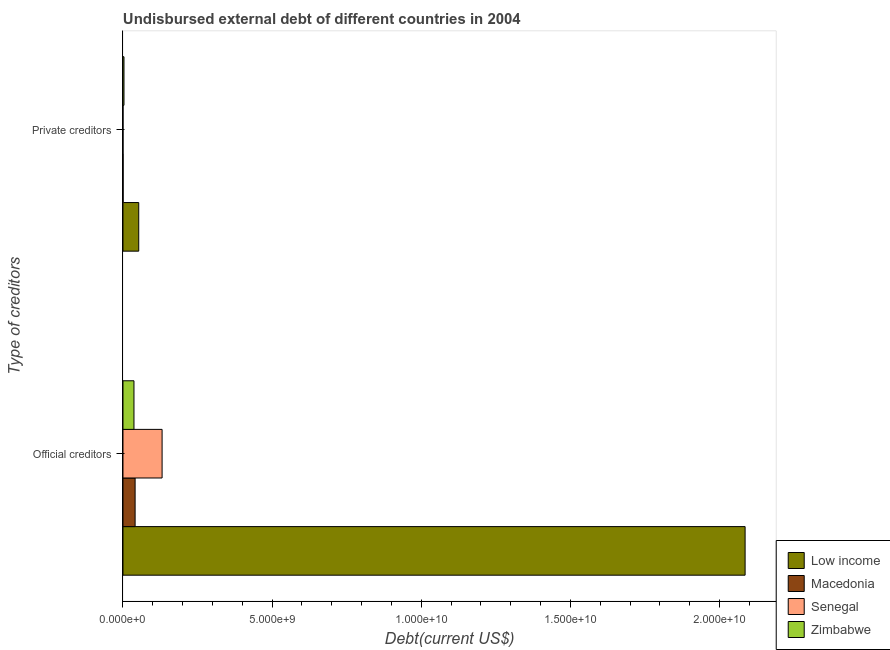How many different coloured bars are there?
Keep it short and to the point. 4. Are the number of bars per tick equal to the number of legend labels?
Your response must be concise. Yes. Are the number of bars on each tick of the Y-axis equal?
Your response must be concise. Yes. How many bars are there on the 2nd tick from the top?
Make the answer very short. 4. What is the label of the 2nd group of bars from the top?
Offer a very short reply. Official creditors. What is the undisbursed external debt of private creditors in Low income?
Provide a succinct answer. 5.28e+08. Across all countries, what is the maximum undisbursed external debt of private creditors?
Offer a very short reply. 5.28e+08. Across all countries, what is the minimum undisbursed external debt of private creditors?
Your response must be concise. 1.41e+05. In which country was the undisbursed external debt of private creditors maximum?
Offer a very short reply. Low income. In which country was the undisbursed external debt of private creditors minimum?
Offer a very short reply. Senegal. What is the total undisbursed external debt of private creditors in the graph?
Provide a short and direct response. 5.66e+08. What is the difference between the undisbursed external debt of official creditors in Low income and that in Senegal?
Provide a succinct answer. 1.95e+1. What is the difference between the undisbursed external debt of official creditors in Senegal and the undisbursed external debt of private creditors in Macedonia?
Your response must be concise. 1.31e+09. What is the average undisbursed external debt of official creditors per country?
Offer a very short reply. 5.74e+09. What is the difference between the undisbursed external debt of private creditors and undisbursed external debt of official creditors in Senegal?
Your answer should be compact. -1.31e+09. What is the ratio of the undisbursed external debt of private creditors in Macedonia to that in Low income?
Offer a very short reply. 0.01. Is the undisbursed external debt of official creditors in Low income less than that in Senegal?
Your answer should be very brief. No. In how many countries, is the undisbursed external debt of official creditors greater than the average undisbursed external debt of official creditors taken over all countries?
Give a very brief answer. 1. What does the 4th bar from the top in Official creditors represents?
Ensure brevity in your answer.  Low income. What does the 4th bar from the bottom in Private creditors represents?
Offer a very short reply. Zimbabwe. Are all the bars in the graph horizontal?
Make the answer very short. Yes. Does the graph contain any zero values?
Provide a succinct answer. No. Does the graph contain grids?
Make the answer very short. No. How many legend labels are there?
Your answer should be compact. 4. What is the title of the graph?
Make the answer very short. Undisbursed external debt of different countries in 2004. What is the label or title of the X-axis?
Your answer should be compact. Debt(current US$). What is the label or title of the Y-axis?
Offer a terse response. Type of creditors. What is the Debt(current US$) in Low income in Official creditors?
Ensure brevity in your answer.  2.09e+1. What is the Debt(current US$) of Macedonia in Official creditors?
Give a very brief answer. 4.07e+08. What is the Debt(current US$) of Senegal in Official creditors?
Keep it short and to the point. 1.31e+09. What is the Debt(current US$) of Zimbabwe in Official creditors?
Give a very brief answer. 3.68e+08. What is the Debt(current US$) in Low income in Private creditors?
Offer a very short reply. 5.28e+08. What is the Debt(current US$) in Macedonia in Private creditors?
Make the answer very short. 4.01e+06. What is the Debt(current US$) of Senegal in Private creditors?
Provide a succinct answer. 1.41e+05. What is the Debt(current US$) in Zimbabwe in Private creditors?
Offer a very short reply. 3.38e+07. Across all Type of creditors, what is the maximum Debt(current US$) of Low income?
Your response must be concise. 2.09e+1. Across all Type of creditors, what is the maximum Debt(current US$) of Macedonia?
Ensure brevity in your answer.  4.07e+08. Across all Type of creditors, what is the maximum Debt(current US$) of Senegal?
Offer a very short reply. 1.31e+09. Across all Type of creditors, what is the maximum Debt(current US$) of Zimbabwe?
Give a very brief answer. 3.68e+08. Across all Type of creditors, what is the minimum Debt(current US$) in Low income?
Offer a terse response. 5.28e+08. Across all Type of creditors, what is the minimum Debt(current US$) in Macedonia?
Provide a short and direct response. 4.01e+06. Across all Type of creditors, what is the minimum Debt(current US$) in Senegal?
Your response must be concise. 1.41e+05. Across all Type of creditors, what is the minimum Debt(current US$) of Zimbabwe?
Your response must be concise. 3.38e+07. What is the total Debt(current US$) in Low income in the graph?
Your answer should be very brief. 2.14e+1. What is the total Debt(current US$) in Macedonia in the graph?
Give a very brief answer. 4.11e+08. What is the total Debt(current US$) of Senegal in the graph?
Your answer should be very brief. 1.31e+09. What is the total Debt(current US$) in Zimbabwe in the graph?
Provide a short and direct response. 4.02e+08. What is the difference between the Debt(current US$) in Low income in Official creditors and that in Private creditors?
Provide a short and direct response. 2.03e+1. What is the difference between the Debt(current US$) in Macedonia in Official creditors and that in Private creditors?
Your response must be concise. 4.03e+08. What is the difference between the Debt(current US$) of Senegal in Official creditors and that in Private creditors?
Your response must be concise. 1.31e+09. What is the difference between the Debt(current US$) in Zimbabwe in Official creditors and that in Private creditors?
Provide a short and direct response. 3.35e+08. What is the difference between the Debt(current US$) of Low income in Official creditors and the Debt(current US$) of Macedonia in Private creditors?
Your answer should be compact. 2.09e+1. What is the difference between the Debt(current US$) of Low income in Official creditors and the Debt(current US$) of Senegal in Private creditors?
Give a very brief answer. 2.09e+1. What is the difference between the Debt(current US$) of Low income in Official creditors and the Debt(current US$) of Zimbabwe in Private creditors?
Your answer should be very brief. 2.08e+1. What is the difference between the Debt(current US$) in Macedonia in Official creditors and the Debt(current US$) in Senegal in Private creditors?
Give a very brief answer. 4.07e+08. What is the difference between the Debt(current US$) of Macedonia in Official creditors and the Debt(current US$) of Zimbabwe in Private creditors?
Give a very brief answer. 3.73e+08. What is the difference between the Debt(current US$) in Senegal in Official creditors and the Debt(current US$) in Zimbabwe in Private creditors?
Give a very brief answer. 1.28e+09. What is the average Debt(current US$) in Low income per Type of creditors?
Your response must be concise. 1.07e+1. What is the average Debt(current US$) of Macedonia per Type of creditors?
Give a very brief answer. 2.05e+08. What is the average Debt(current US$) of Senegal per Type of creditors?
Your response must be concise. 6.56e+08. What is the average Debt(current US$) in Zimbabwe per Type of creditors?
Your response must be concise. 2.01e+08. What is the difference between the Debt(current US$) in Low income and Debt(current US$) in Macedonia in Official creditors?
Keep it short and to the point. 2.04e+1. What is the difference between the Debt(current US$) of Low income and Debt(current US$) of Senegal in Official creditors?
Give a very brief answer. 1.95e+1. What is the difference between the Debt(current US$) of Low income and Debt(current US$) of Zimbabwe in Official creditors?
Provide a succinct answer. 2.05e+1. What is the difference between the Debt(current US$) in Macedonia and Debt(current US$) in Senegal in Official creditors?
Offer a terse response. -9.04e+08. What is the difference between the Debt(current US$) in Macedonia and Debt(current US$) in Zimbabwe in Official creditors?
Offer a very short reply. 3.83e+07. What is the difference between the Debt(current US$) in Senegal and Debt(current US$) in Zimbabwe in Official creditors?
Your response must be concise. 9.43e+08. What is the difference between the Debt(current US$) in Low income and Debt(current US$) in Macedonia in Private creditors?
Provide a succinct answer. 5.24e+08. What is the difference between the Debt(current US$) in Low income and Debt(current US$) in Senegal in Private creditors?
Make the answer very short. 5.28e+08. What is the difference between the Debt(current US$) in Low income and Debt(current US$) in Zimbabwe in Private creditors?
Keep it short and to the point. 4.94e+08. What is the difference between the Debt(current US$) of Macedonia and Debt(current US$) of Senegal in Private creditors?
Ensure brevity in your answer.  3.87e+06. What is the difference between the Debt(current US$) in Macedonia and Debt(current US$) in Zimbabwe in Private creditors?
Offer a very short reply. -2.98e+07. What is the difference between the Debt(current US$) of Senegal and Debt(current US$) of Zimbabwe in Private creditors?
Offer a very short reply. -3.36e+07. What is the ratio of the Debt(current US$) of Low income in Official creditors to that in Private creditors?
Give a very brief answer. 39.5. What is the ratio of the Debt(current US$) of Macedonia in Official creditors to that in Private creditors?
Provide a succinct answer. 101.43. What is the ratio of the Debt(current US$) in Senegal in Official creditors to that in Private creditors?
Provide a succinct answer. 9298.48. What is the ratio of the Debt(current US$) of Zimbabwe in Official creditors to that in Private creditors?
Keep it short and to the point. 10.91. What is the difference between the highest and the second highest Debt(current US$) of Low income?
Offer a very short reply. 2.03e+1. What is the difference between the highest and the second highest Debt(current US$) in Macedonia?
Give a very brief answer. 4.03e+08. What is the difference between the highest and the second highest Debt(current US$) in Senegal?
Give a very brief answer. 1.31e+09. What is the difference between the highest and the second highest Debt(current US$) of Zimbabwe?
Provide a succinct answer. 3.35e+08. What is the difference between the highest and the lowest Debt(current US$) in Low income?
Provide a short and direct response. 2.03e+1. What is the difference between the highest and the lowest Debt(current US$) in Macedonia?
Your answer should be compact. 4.03e+08. What is the difference between the highest and the lowest Debt(current US$) in Senegal?
Offer a terse response. 1.31e+09. What is the difference between the highest and the lowest Debt(current US$) of Zimbabwe?
Keep it short and to the point. 3.35e+08. 